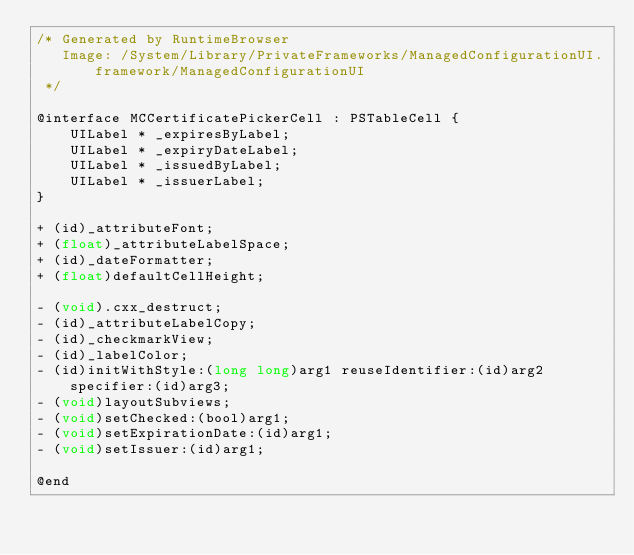<code> <loc_0><loc_0><loc_500><loc_500><_C_>/* Generated by RuntimeBrowser
   Image: /System/Library/PrivateFrameworks/ManagedConfigurationUI.framework/ManagedConfigurationUI
 */

@interface MCCertificatePickerCell : PSTableCell {
    UILabel * _expiresByLabel;
    UILabel * _expiryDateLabel;
    UILabel * _issuedByLabel;
    UILabel * _issuerLabel;
}

+ (id)_attributeFont;
+ (float)_attributeLabelSpace;
+ (id)_dateFormatter;
+ (float)defaultCellHeight;

- (void).cxx_destruct;
- (id)_attributeLabelCopy;
- (id)_checkmarkView;
- (id)_labelColor;
- (id)initWithStyle:(long long)arg1 reuseIdentifier:(id)arg2 specifier:(id)arg3;
- (void)layoutSubviews;
- (void)setChecked:(bool)arg1;
- (void)setExpirationDate:(id)arg1;
- (void)setIssuer:(id)arg1;

@end
</code> 